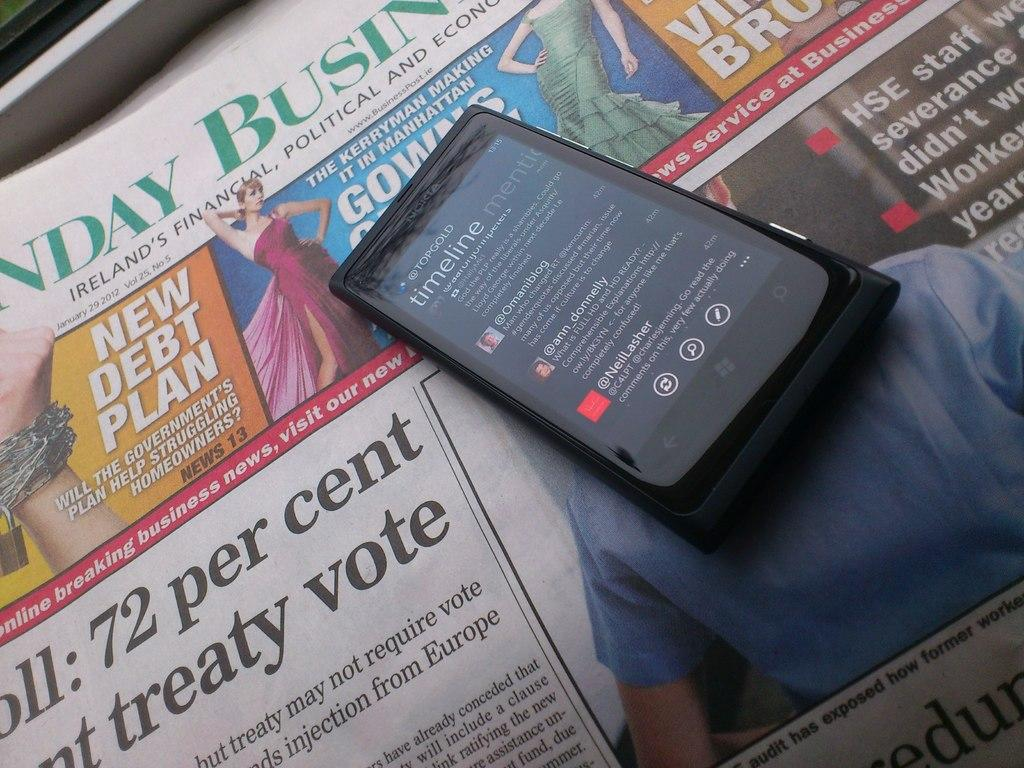<image>
Provide a brief description of the given image. A cell phone lies on the front page of an Irish newspaper. 